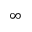Convert formula to latex. <formula><loc_0><loc_0><loc_500><loc_500>\infty</formula> 